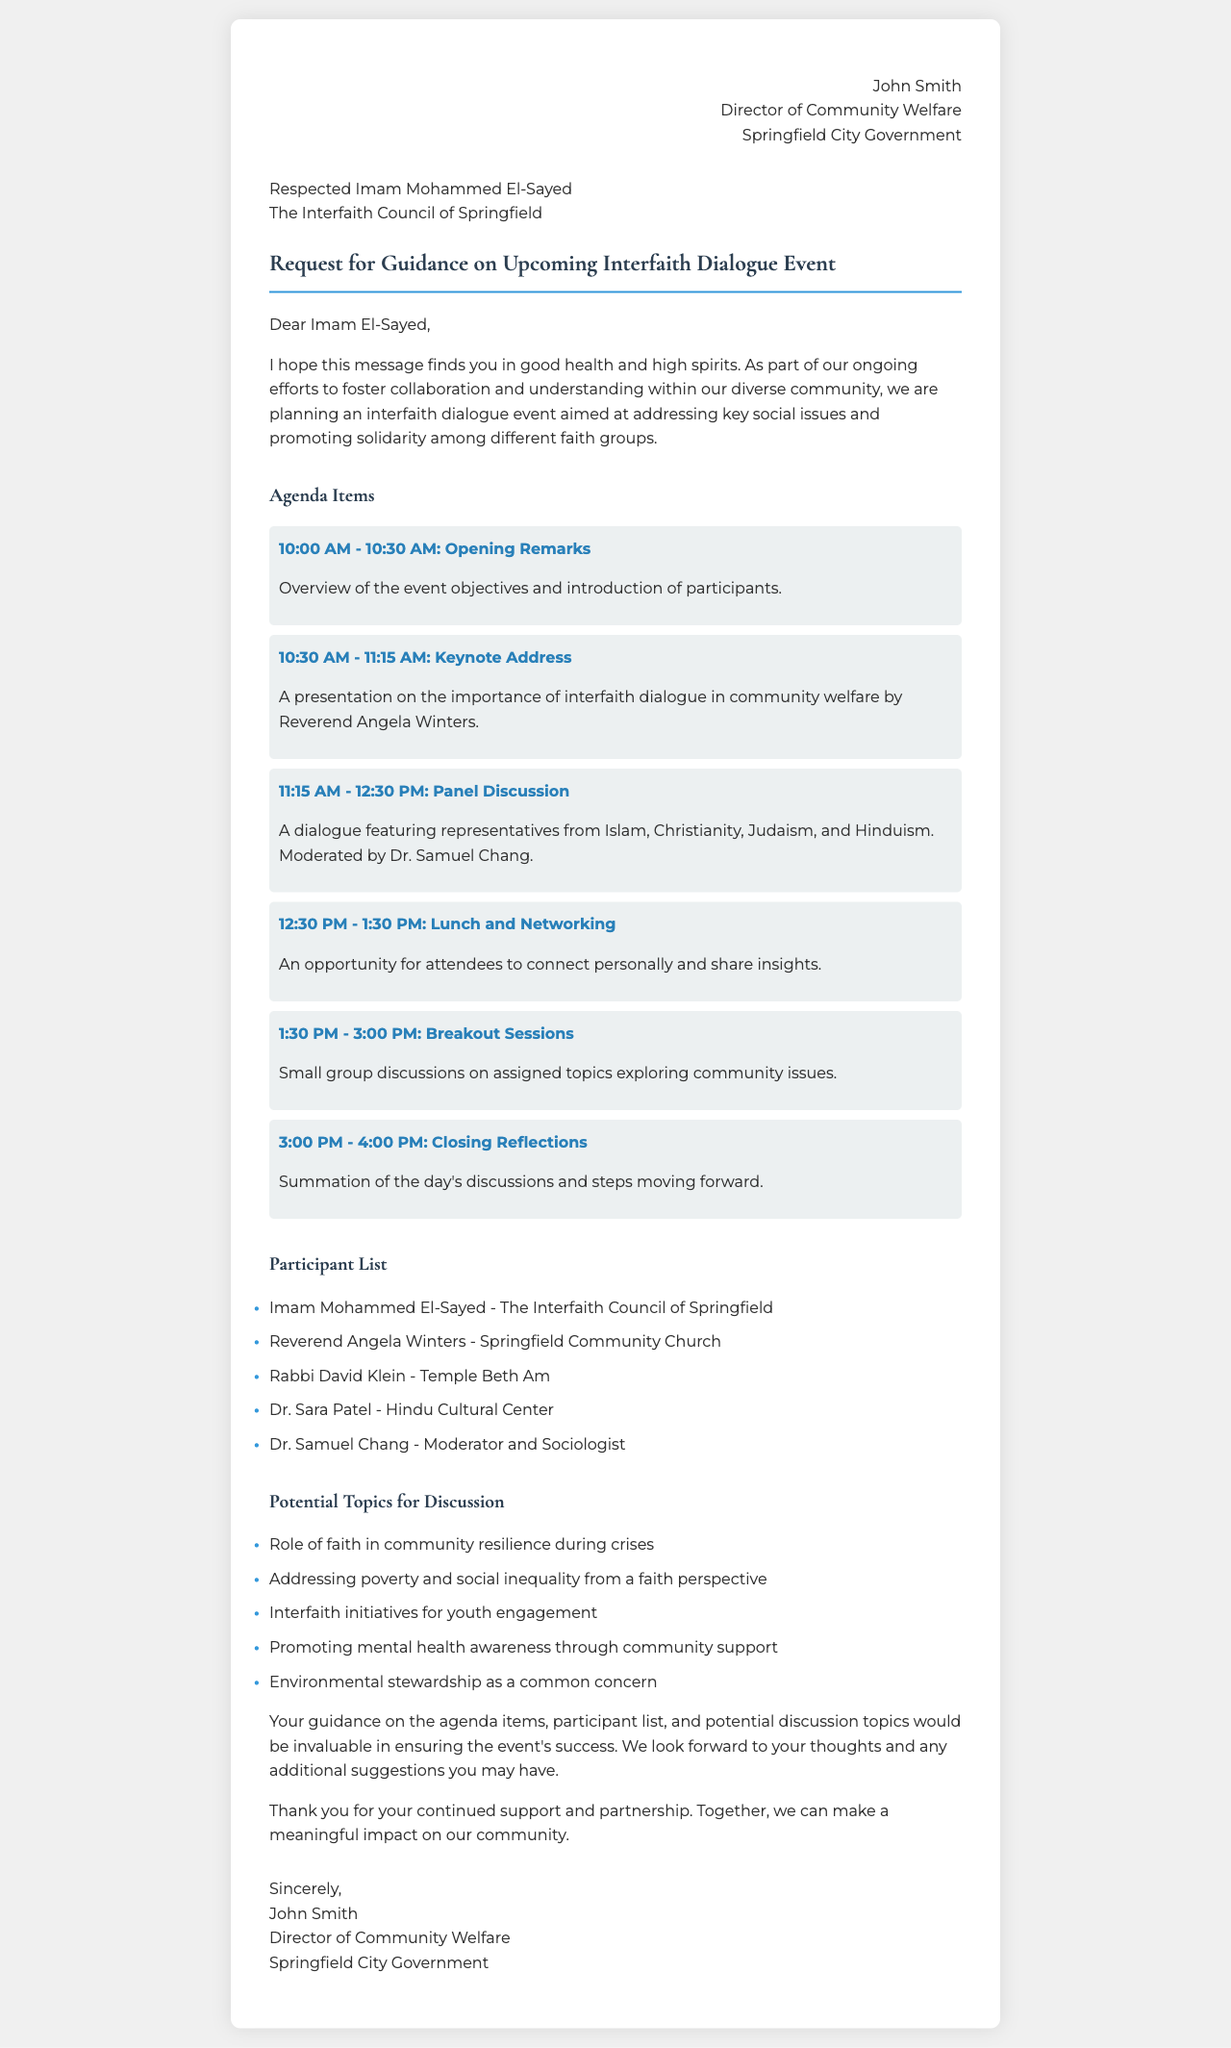what is the date and time of the opening remarks? The opening remarks are scheduled to take place from 10:00 AM to 10:30 AM.
Answer: 10:00 AM - 10:30 AM who is delivering the keynote address? The keynote address will be delivered by Reverend Angela Winters.
Answer: Reverend Angela Winters how many participants are listed in the participant list? There are five participants listed in the participant list.
Answer: 5 what is one potential topic for discussion mentioned in the document? One potential topic for discussion is "Role of faith in community resilience during crises."
Answer: Role of faith in community resilience during crises who is moderating the panel discussion? The panel discussion will be moderated by Dr. Samuel Chang.
Answer: Dr. Samuel Chang what is the purpose of the interfaith dialogue event? The event aims to address key social issues and promote solidarity among different faith groups.
Answer: addressing key social issues and promoting solidarity what time is the closing reflections scheduled? The closing reflections are scheduled for 3:00 PM to 4:00 PM.
Answer: 3:00 PM - 4:00 PM what is the title of the document? The title of the document is "Request for Guidance on Upcoming Interfaith Dialogue Event."
Answer: Request for Guidance on Upcoming Interfaith Dialogue Event what is the role of John Smith? John Smith is the Director of Community Welfare.
Answer: Director of Community Welfare 